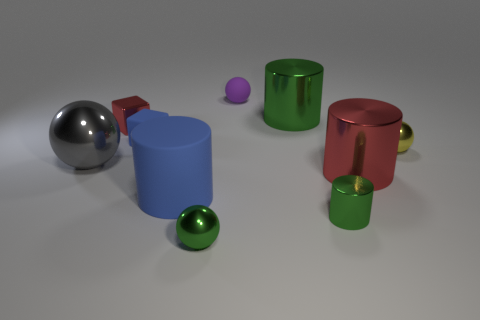What size is the yellow sphere?
Your answer should be very brief. Small. Are there any big shiny objects of the same color as the small rubber ball?
Offer a terse response. No. What number of tiny objects are either matte objects or blue blocks?
Your response must be concise. 2. What size is the metallic object that is left of the big green thing and in front of the large gray ball?
Provide a succinct answer. Small. What number of large gray metallic objects are to the right of the gray metal sphere?
Provide a short and direct response. 0. What shape is the tiny thing that is both behind the tiny yellow thing and on the right side of the green metallic sphere?
Your answer should be compact. Sphere. What material is the tiny ball that is the same color as the tiny cylinder?
Offer a terse response. Metal. What number of balls are either big green objects or tiny purple rubber objects?
Provide a short and direct response. 1. What is the size of the thing that is the same color as the big rubber cylinder?
Keep it short and to the point. Small. Are there fewer rubber spheres in front of the gray thing than gray shiny balls?
Provide a succinct answer. Yes. 